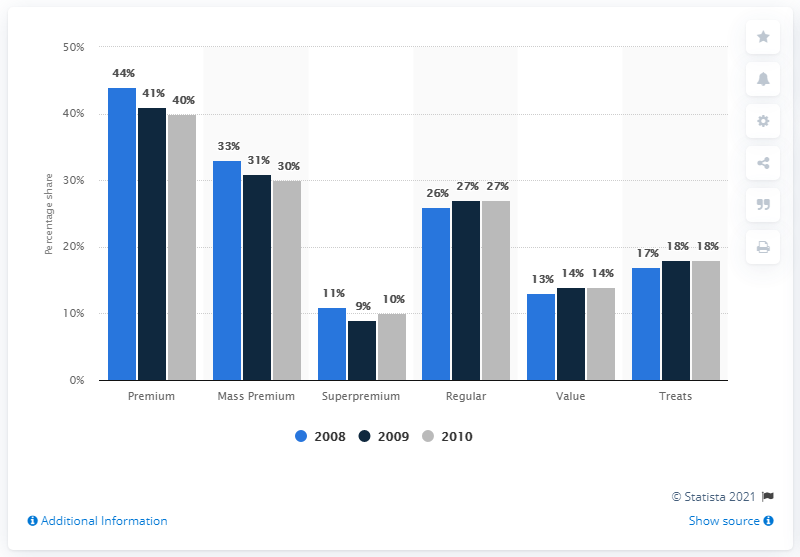What does the image suggest about the market for 'Value' and 'Treats' categories in the years provided? The image shows stability in the 'Value' category, holding steady at 1% over the three years. In contrast, the 'Treats' category shows an upward trend with sales increasing from 17% in 2008 to 18% in both 2009 and 2010, indicating a growing interest in this segment. 